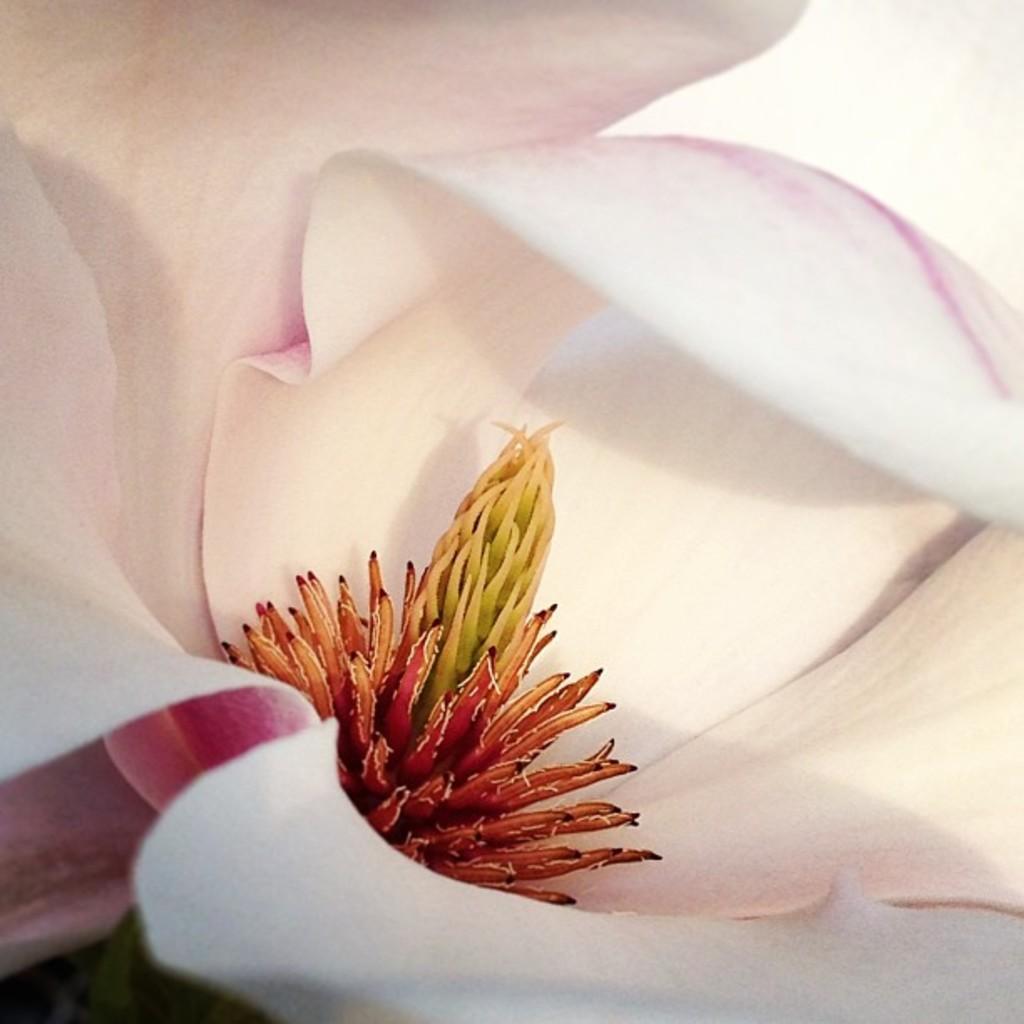Please provide a concise description of this image. It is a zoom in picture of white color flower. 